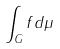<formula> <loc_0><loc_0><loc_500><loc_500>\int _ { G } f d \mu</formula> 